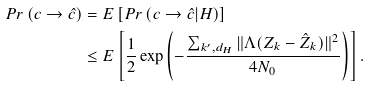Convert formula to latex. <formula><loc_0><loc_0><loc_500><loc_500>P r \left ( c \rightarrow \hat { c } \right ) & = E \left [ P r \left ( c \rightarrow \hat { c } | H \right ) \right ] \\ & \leq E \left [ \frac { 1 } { 2 } \exp \left ( - \frac { \sum _ { k ^ { \prime } , d _ { H } } \| \Lambda ( Z _ { k } - \hat { Z } _ { k } ) \| ^ { 2 } } { 4 N _ { 0 } } \right ) \right ] .</formula> 